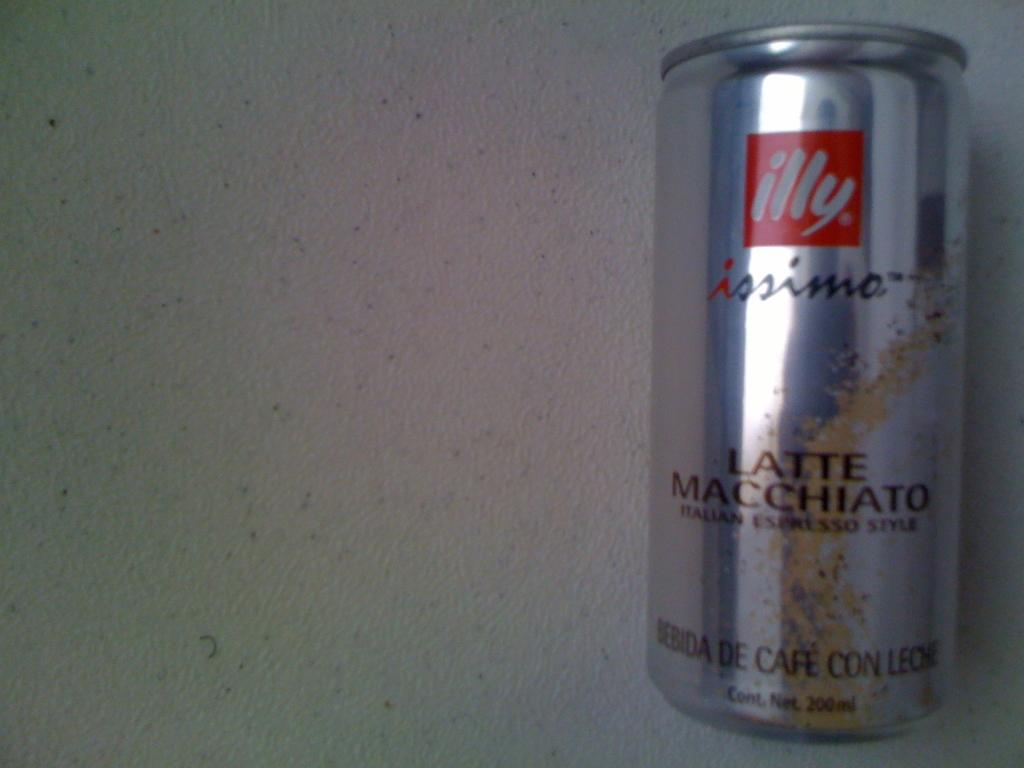<image>
Provide a brief description of the given image. A silver can has the words Latte Macchiato on it. 